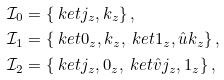<formula> <loc_0><loc_0><loc_500><loc_500>\mathcal { I } _ { 0 } & = \{ \ k e t { j _ { z } , k _ { z } } \} \, , \\ \mathcal { I } _ { 1 } & = \{ \ k e t { 0 _ { z } , k _ { z } } , \ k e t { 1 _ { z } , \hat { u } k _ { z } } \} \, , \\ \mathcal { I } _ { 2 } & = \{ \ k e t { j _ { z } , 0 _ { z } } , \ k e t { \hat { v } j _ { z } , 1 _ { z } } \} \, ,</formula> 